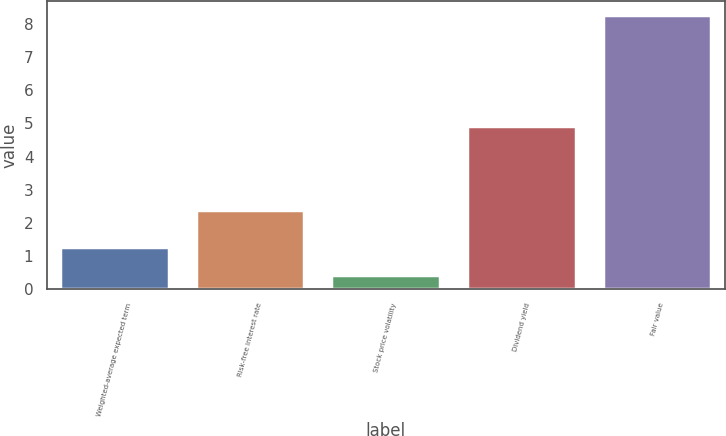<chart> <loc_0><loc_0><loc_500><loc_500><bar_chart><fcel>Weighted-average expected term<fcel>Risk-free interest rate<fcel>Stock price volatility<fcel>Dividend yield<fcel>Fair value<nl><fcel>1.26<fcel>2.39<fcel>0.41<fcel>4.92<fcel>8.28<nl></chart> 